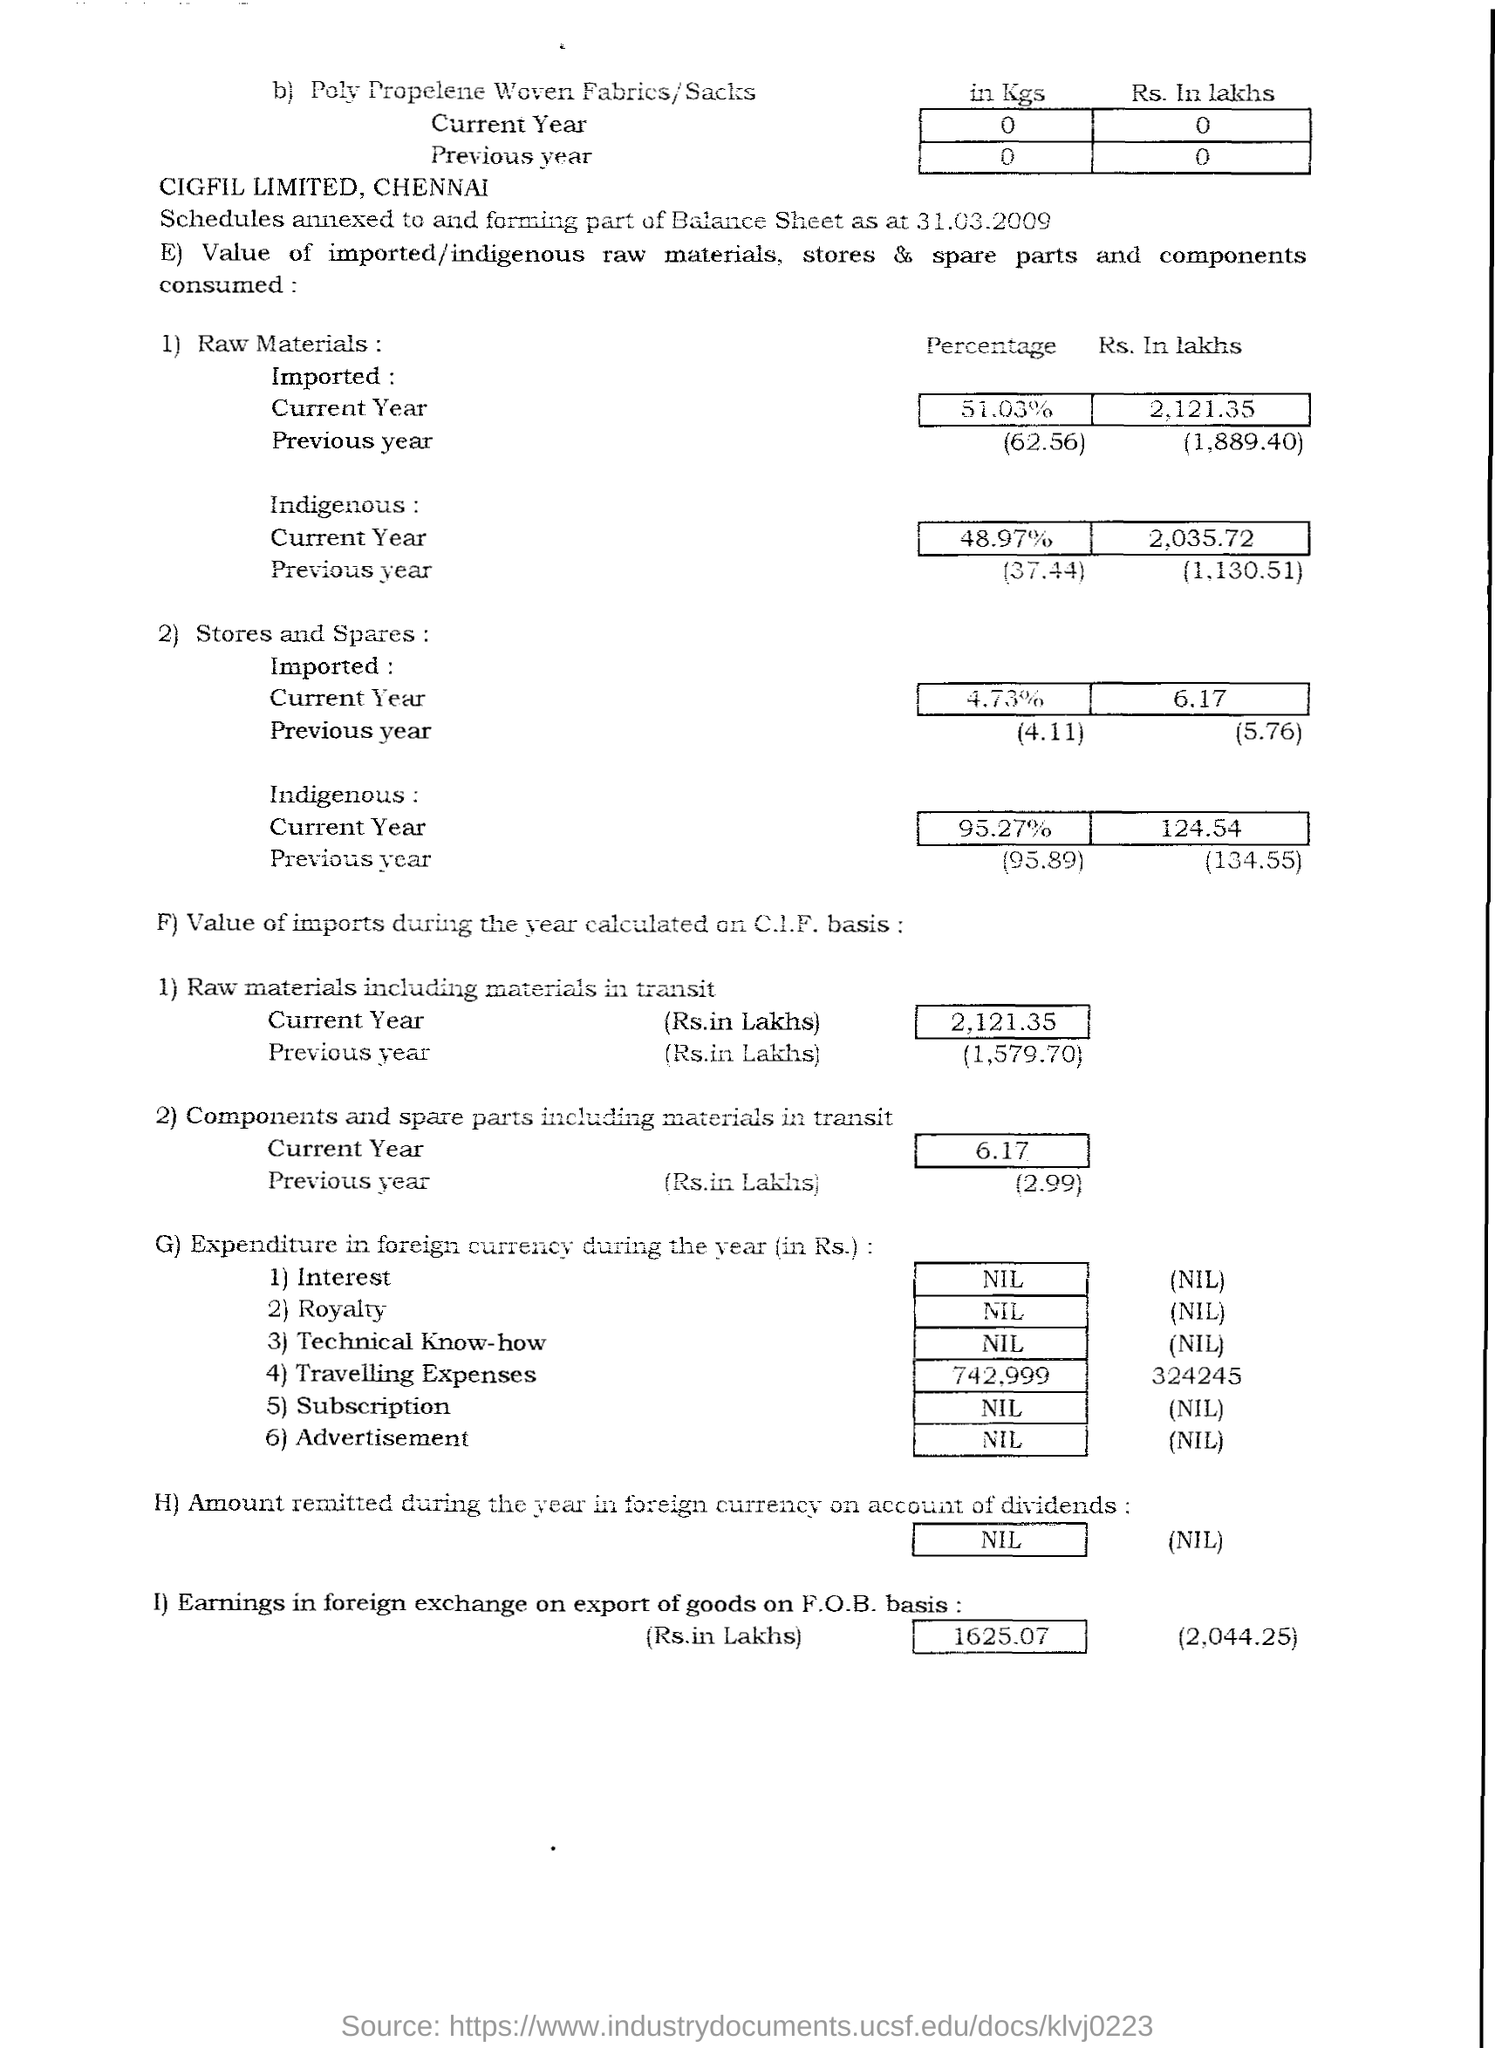What is the "Percentage" of Raw Materials Imported in the "Current Year"?
Offer a terse response. 51.03%. What is the "Percentage" of Raw Materials Imported in the "Previous Year"?
Ensure brevity in your answer.  62.56. What is the "Rs. In lakhs" of Raw Materials Imported in the "Current Year"?
Offer a terse response. 2,121.35. What is the "Rs. In lakhs" of Raw Materials Imported in the "Previous Year"?
Offer a very short reply. (1889.40). What is the "Percentage" of Raw Materials Indigenous in the "Previous Year"?
Give a very brief answer. 37.44. What is the "Percentage" of Raw Materials Indigenous in the "Current Year"?
Your answer should be very brief. 48.97%. What is the "Percentage" of Stores and Spares Indigenous in the "Previous Year"?
Keep it short and to the point. (95.89). What is the "Percentage" of Stores and Spares Indigenous in the "Current Year"?
Give a very brief answer. 95.27%. What is the "Percentage" of Stores and Spares Imported in the "Previous Year"?
Your response must be concise. 4.11. What is the "Percentage" of Stores and Spares Imported in the "Current Year"?
Offer a very short reply. 4.73%. 